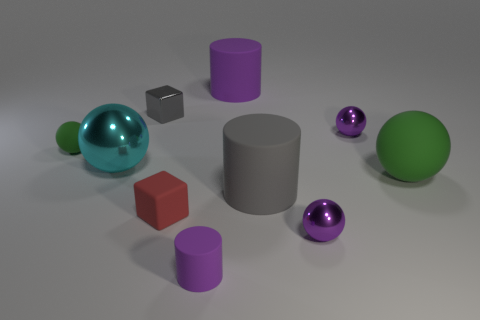Subtract all purple metallic balls. How many balls are left? 3 Subtract all red balls. How many purple cylinders are left? 2 Subtract all green spheres. How many spheres are left? 3 Subtract 1 cylinders. How many cylinders are left? 2 Subtract all yellow balls. Subtract all red blocks. How many balls are left? 5 Subtract all cubes. How many objects are left? 8 Subtract all yellow metallic balls. Subtract all small rubber balls. How many objects are left? 9 Add 6 small green matte things. How many small green matte things are left? 7 Add 6 cyan spheres. How many cyan spheres exist? 7 Subtract 2 green balls. How many objects are left? 8 